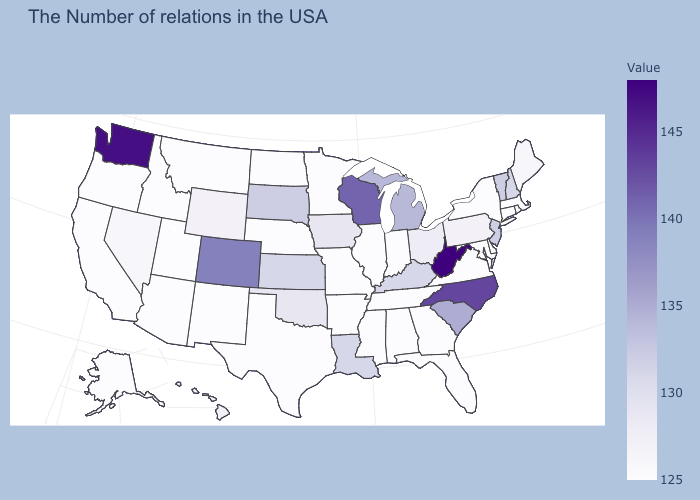Which states have the lowest value in the USA?
Concise answer only. Massachusetts, Rhode Island, Connecticut, New York, Delaware, Maryland, Virginia, Florida, Georgia, Indiana, Alabama, Tennessee, Illinois, Mississippi, Missouri, Arkansas, Minnesota, Nebraska, Texas, North Dakota, New Mexico, Utah, Montana, Arizona, Idaho, California, Oregon, Alaska. Does Delaware have the lowest value in the USA?
Concise answer only. Yes. Among the states that border South Carolina , which have the highest value?
Short answer required. North Carolina. Among the states that border Kentucky , which have the highest value?
Answer briefly. West Virginia. Does the map have missing data?
Write a very short answer. No. Does Ohio have the lowest value in the USA?
Give a very brief answer. No. Does North Carolina have the lowest value in the USA?
Be succinct. No. Does South Carolina have a higher value than Utah?
Give a very brief answer. Yes. Does West Virginia have the highest value in the USA?
Quick response, please. Yes. 